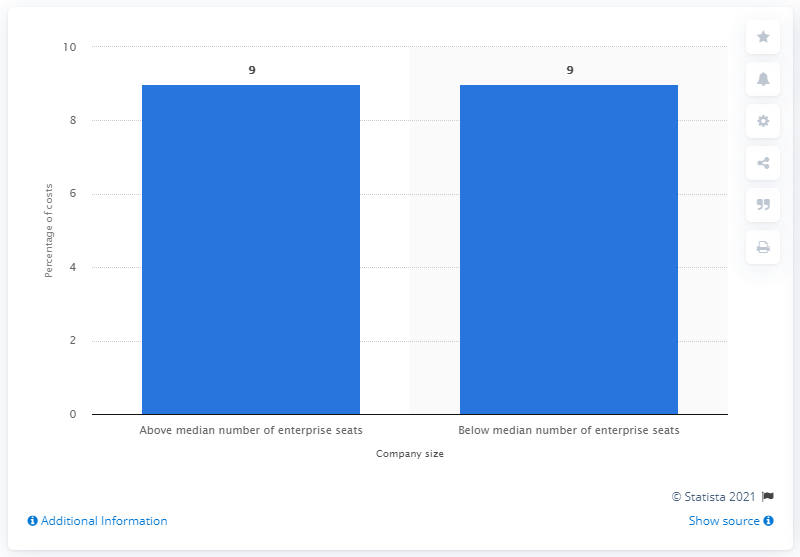Highlight a few significant elements in this photo. According to the study, companies with fewer than 13,251 enterprise seats incurred 9% of the total cost of cyber crime. 